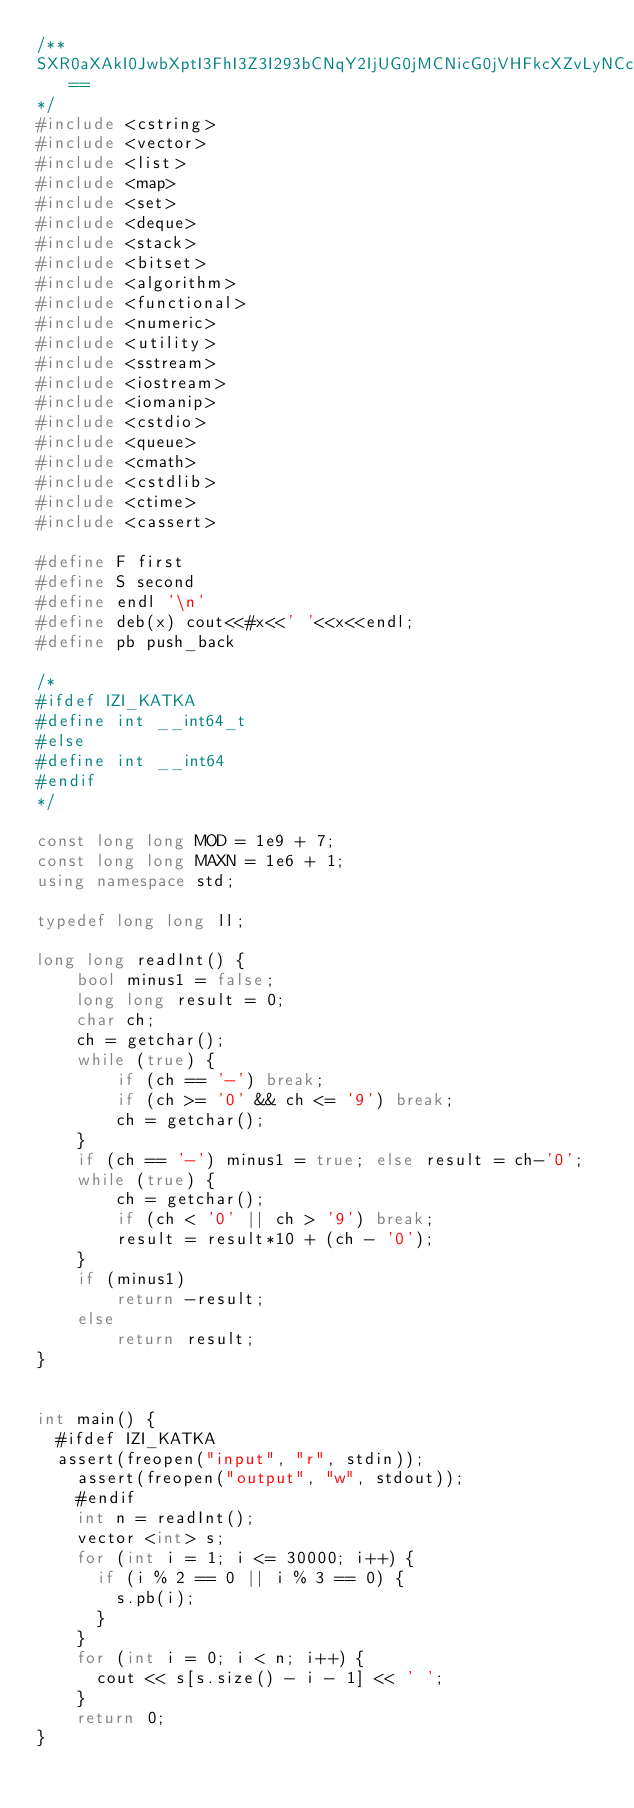<code> <loc_0><loc_0><loc_500><loc_500><_C++_>/**
SXR0aXAkI0JwbXptI3FhI3Z3I293bCNqY2IjUG0jMCNicG0jVHFkcXZvLyNCcG0jQW10bjBhY2phcWFicXZvLyNNYm16dml0MSNWdyNhdGN1am16I2tpdiNhbXF9bSNQcXUjVnd6I0F0bW14MSNQcWEjaXptI2l0dCNicHF2b2EjUXYjYnBtI3BtaWRtdmEjaXZsI3d2I21pemJwMSNFcHcjcWEjYnBtem0ja2l2I3F2Ym16a21sbSNRdiNQcWEjeHptYW12a20jbXtrbXhiI0lhI3BtI3htenVxYmJtYnBHI1BtI3N2d2VtYnAjRXBpYiMraXh4bWl6bWJwI2J3I1BxYSNrem1pYmN6bWEjSWEsI0ptbnd6bSN3eiNJbmJteiN3eiNKbXBxdmwjYnBtdTEjVnd6I2FwaXR0I2JwbXwja3d1eGlhYSNJY29wYiN3biNwcWEjc3Z3ZXRtbG9tI017a214YiNpYSNQbSNlcXR0bWJwMSNQcWEjYnB6d3ZtI2x3YnAjbXtibXZsI1dkbXojYnBtI3BtaWRtdmEjSXZsI3d2I21pemJwLyNpdmwjUG0jbm1tdG1icCNWdyNuaWJxb2NtI3F2I29jaXpscXZvI0l2bCN4em1hbXpkcXZvI2JwbXUvI053eiNQbSNxYSNicG0jVXdhYiNQcW9wMSNCcG0jQWN4em11bSMrcXYjb3R3enwsMQ==
*/
#include <cstring>
#include <vector>
#include <list>
#include <map>
#include <set>
#include <deque>
#include <stack>
#include <bitset>
#include <algorithm>
#include <functional>
#include <numeric>
#include <utility>
#include <sstream>
#include <iostream>
#include <iomanip>
#include <cstdio>
#include <queue>
#include <cmath>
#include <cstdlib>
#include <ctime>
#include <cassert>

#define F first
#define S second
#define endl '\n'
#define deb(x) cout<<#x<<' '<<x<<endl;
#define pb push_back

/*
#ifdef IZI_KATKA
#define int __int64_t
#else
#define int __int64
#endif
*/

const long long MOD = 1e9 + 7;
const long long MAXN = 1e6 + 1;
using namespace std;

typedef long long ll;

long long readInt() {
    bool minus1 = false;
    long long result = 0;
    char ch;
    ch = getchar();
    while (true) {
        if (ch == '-') break;
        if (ch >= '0' && ch <= '9') break;
        ch = getchar();
    }
    if (ch == '-') minus1 = true; else result = ch-'0';
    while (true) {
        ch = getchar();
        if (ch < '0' || ch > '9') break;
        result = result*10 + (ch - '0');
    }
    if (minus1)
        return -result;
    else
        return result;
}


int main() {
	#ifdef IZI_KATKA
	assert(freopen("input", "r", stdin));
    assert(freopen("output", "w", stdout));
    #endif
    int n = readInt();
    vector <int> s;
    for (int i = 1; i <= 30000; i++) {
    	if (i % 2 == 0 || i % 3 == 0) {
    		s.pb(i);
    	}
    }
    for (int i = 0; i < n; i++) {
    	cout << s[s.size() - i - 1] << ' ';
    }
    return 0;
}</code> 